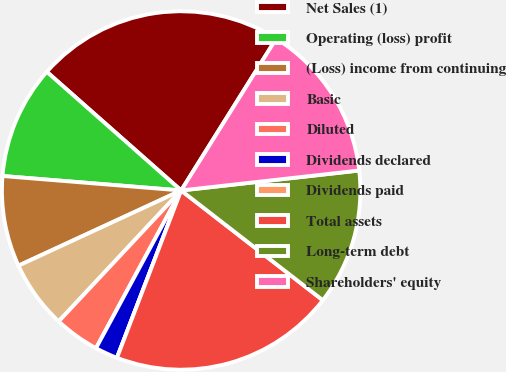Convert chart to OTSL. <chart><loc_0><loc_0><loc_500><loc_500><pie_chart><fcel>Net Sales (1)<fcel>Operating (loss) profit<fcel>(Loss) income from continuing<fcel>Basic<fcel>Diluted<fcel>Dividends declared<fcel>Dividends paid<fcel>Total assets<fcel>Long-term debt<fcel>Shareholders' equity<nl><fcel>22.39%<fcel>10.23%<fcel>8.18%<fcel>6.14%<fcel>4.09%<fcel>2.05%<fcel>0.0%<fcel>20.34%<fcel>12.27%<fcel>14.32%<nl></chart> 